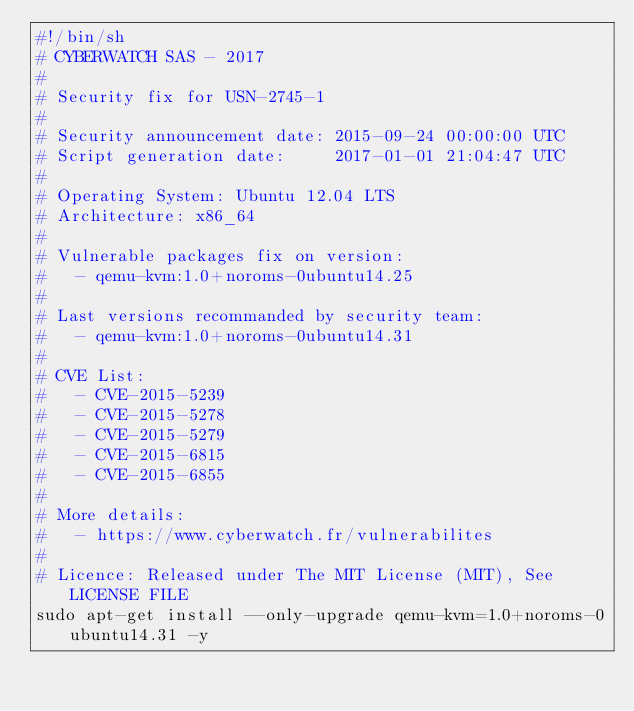Convert code to text. <code><loc_0><loc_0><loc_500><loc_500><_Bash_>#!/bin/sh
# CYBERWATCH SAS - 2017
#
# Security fix for USN-2745-1
#
# Security announcement date: 2015-09-24 00:00:00 UTC
# Script generation date:     2017-01-01 21:04:47 UTC
#
# Operating System: Ubuntu 12.04 LTS
# Architecture: x86_64
#
# Vulnerable packages fix on version:
#   - qemu-kvm:1.0+noroms-0ubuntu14.25
#
# Last versions recommanded by security team:
#   - qemu-kvm:1.0+noroms-0ubuntu14.31
#
# CVE List:
#   - CVE-2015-5239
#   - CVE-2015-5278
#   - CVE-2015-5279
#   - CVE-2015-6815
#   - CVE-2015-6855
#
# More details:
#   - https://www.cyberwatch.fr/vulnerabilites
#
# Licence: Released under The MIT License (MIT), See LICENSE FILE
sudo apt-get install --only-upgrade qemu-kvm=1.0+noroms-0ubuntu14.31 -y
</code> 